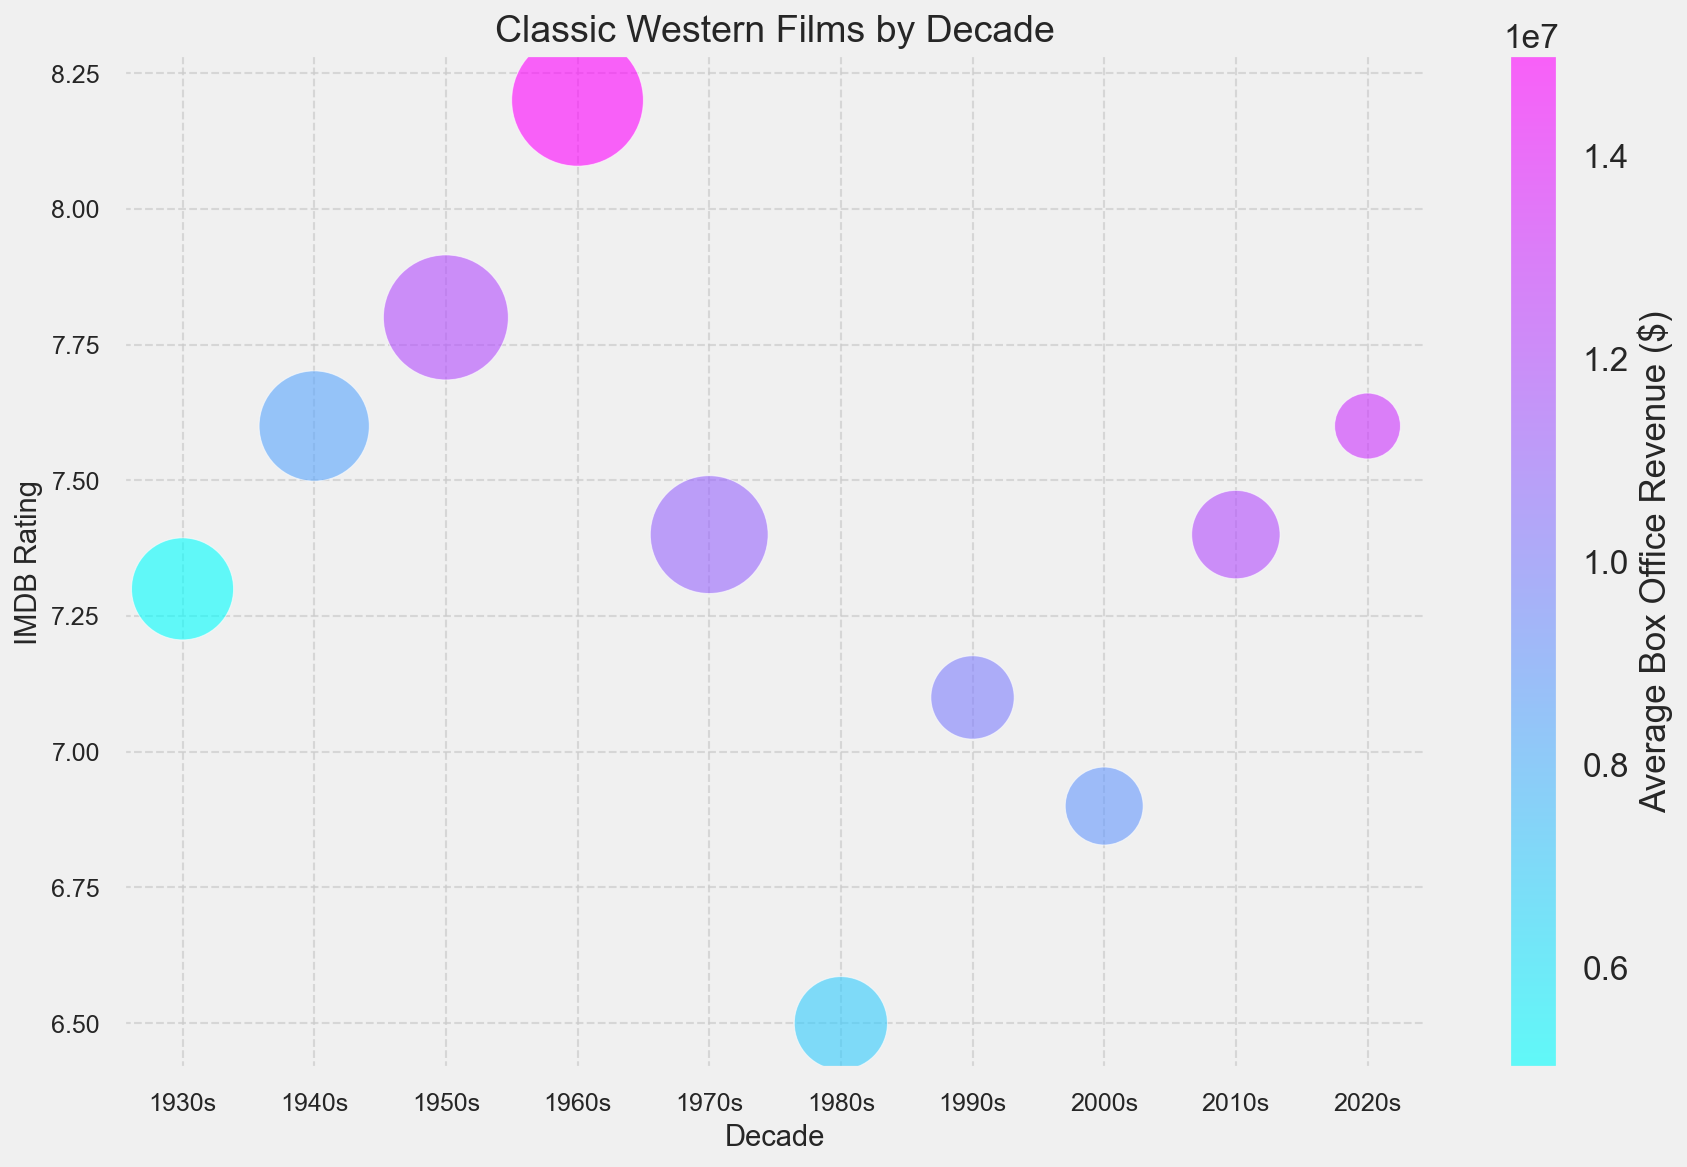What is the average IMDB rating for Classic Western Films in the 1960s? The bubble representing the 1960s has an IMDB rating positioned at 8.2 on the y-axis.
Answer: 8.2 Which decade had the highest average box office revenue? The color bar indicates the average box office revenue. The darkest bubble, indicating the highest revenue, is from the 1960s.
Answer: 1960s Compare the number of films produced in the 1950s and 2010s. Which decade produced more films? The size of the bubble corresponds to the number of films. The 1950s has a larger bubble compared to the 2010s.
Answer: 1950s What is the trend in average IMDB rating from the 1930s to the 1960s? Look at the position of the bubbles from the 1930s to 1960s. The IMDB ratings increase from the 1930s (7.3) to the 1960s (8.2).
Answer: Increasing How does the average box office revenue in the 1980s compare with the 2000s? The color of the bubble for the 1980s is lighter than for the 2000s, indicating a lower average box office revenue.
Answer: Lower in the 1980s Which decade had the lowest average box office revenue? The bubble with the lightest color in the color gradient represents the 1930s.
Answer: 1930s Calculate the average number of films produced from the 2000s to the 2020s. The numbers of films produced are 7 in the 2000s, 9 in the 2010s, and 5 in the 2020s. Average number of films = (7 + 9 + 5) / 3 = 7.
Answer: 7 What is the overall trend in box office revenue from the 1930s to the 2020s? The color bar indicates that the color of bubbles generally becomes darker from the 1930s to the 2020s, showing an increase in average box office revenue.
Answer: Increasing Compare the average IMDB ratings of the 1970s and the 2010s. Which decade has a higher rating? The bubble for the 1970s is positioned at 7.4 and the 2010s at 7.4 on the y-axis, indicating equal ratings.
Answer: Equal What is the difference in the number of films made between the 1940s and the 1990s? 14 films were made in the 1940s and 8 in the 1990s. Difference = 14 - 8 = 6.
Answer: 6 